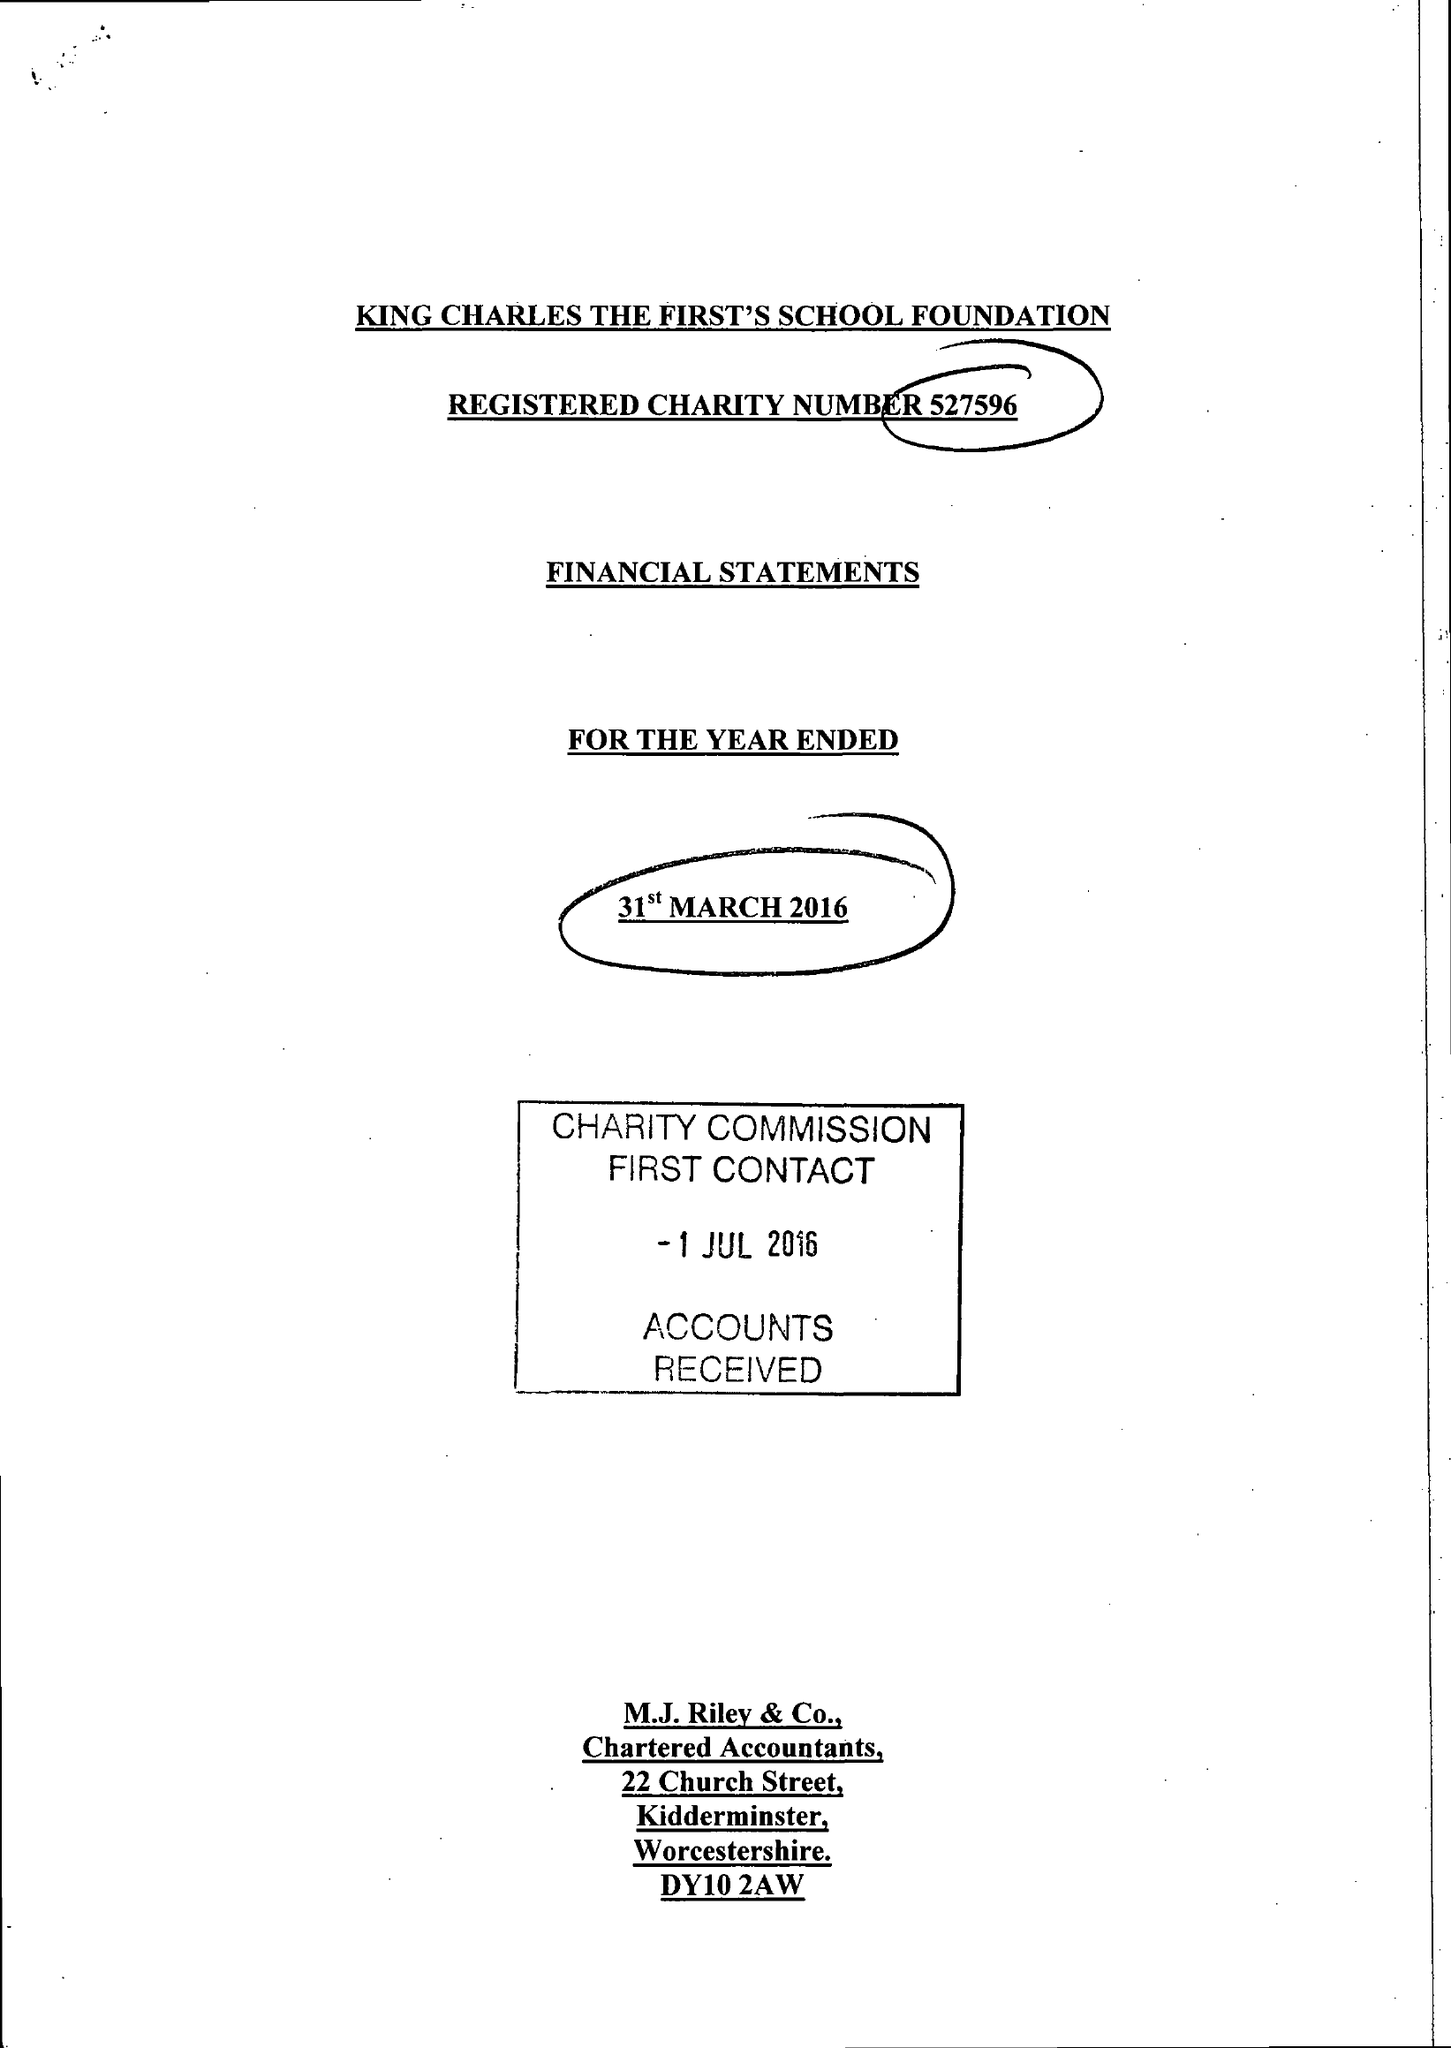What is the value for the charity_name?
Answer the question using a single word or phrase. King Charles The First's School Foundation 